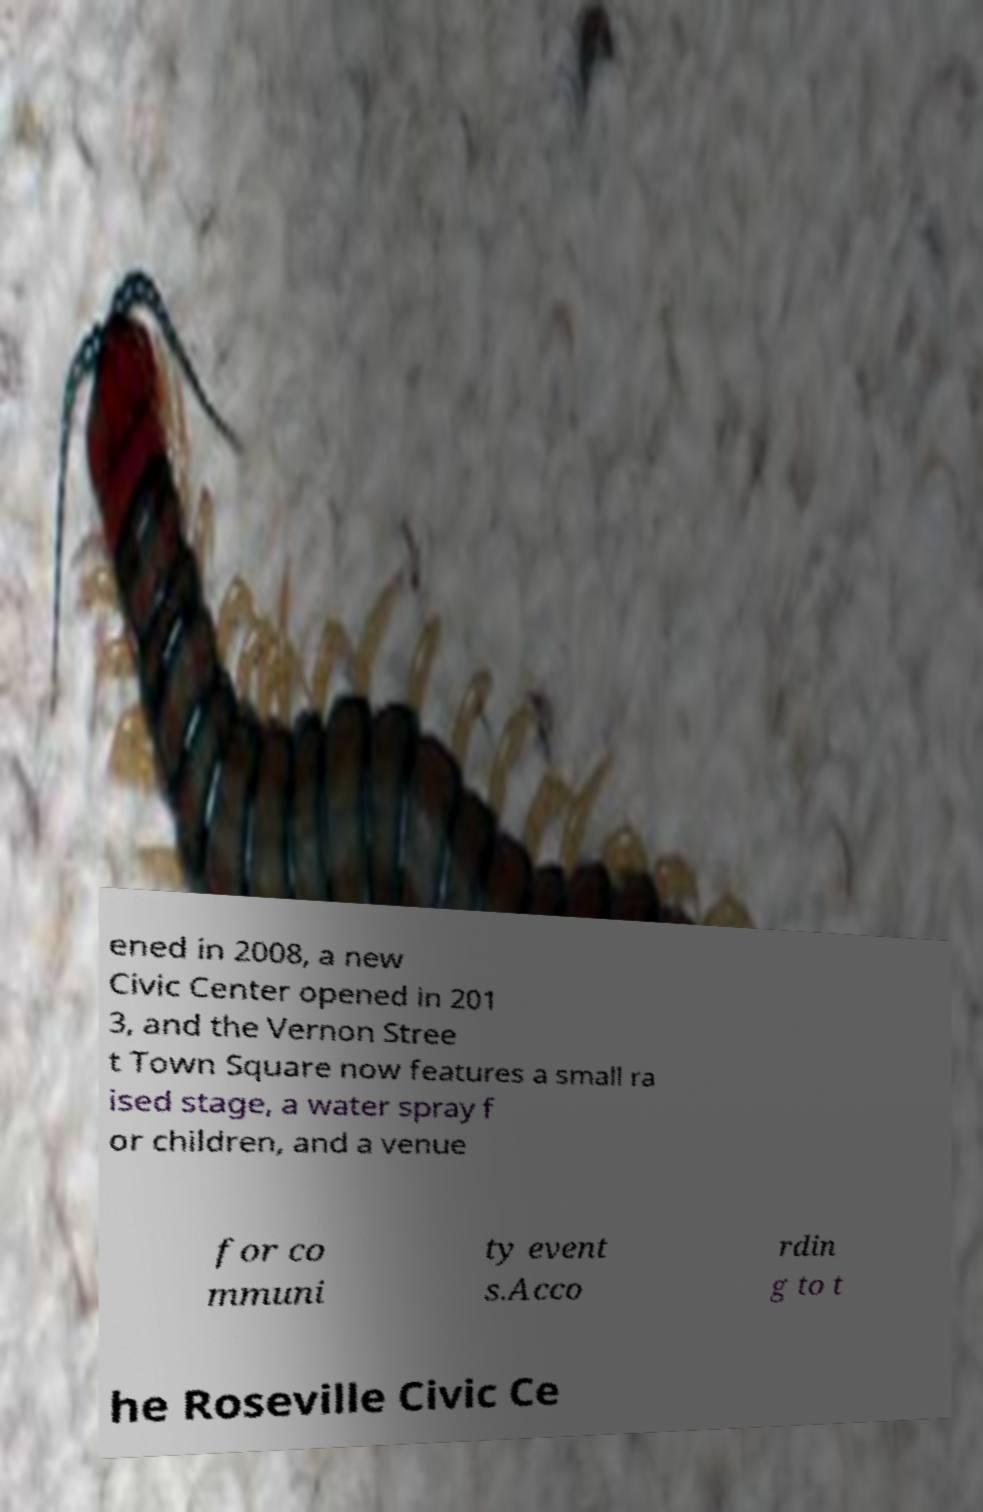There's text embedded in this image that I need extracted. Can you transcribe it verbatim? ened in 2008, a new Civic Center opened in 201 3, and the Vernon Stree t Town Square now features a small ra ised stage, a water spray f or children, and a venue for co mmuni ty event s.Acco rdin g to t he Roseville Civic Ce 